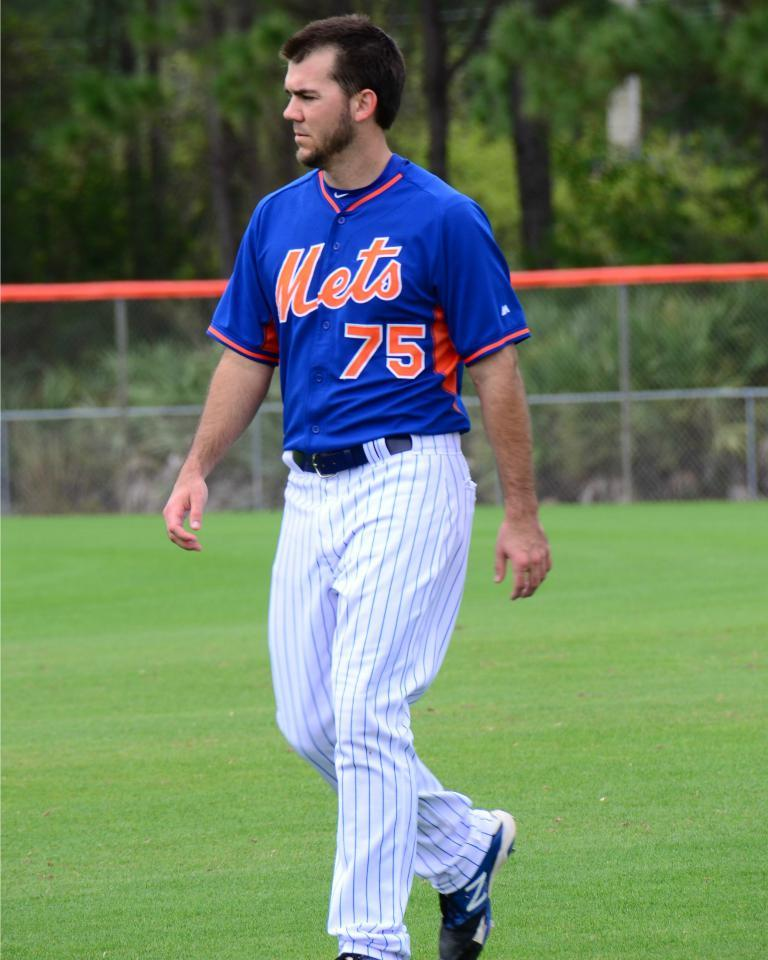<image>
Render a clear and concise summary of the photo. A man with a Mets uniform standing on a grassy field. 